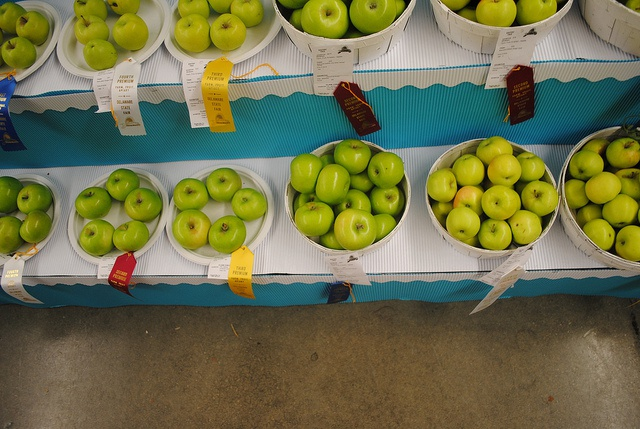Describe the objects in this image and their specific colors. I can see bowl in darkblue, olive, black, and gold tones, bowl in darkblue, olive, and black tones, apple in darkblue, olive, gold, and black tones, bowl in darkblue, olive, black, and gray tones, and apple in darkblue, olive, and black tones in this image. 